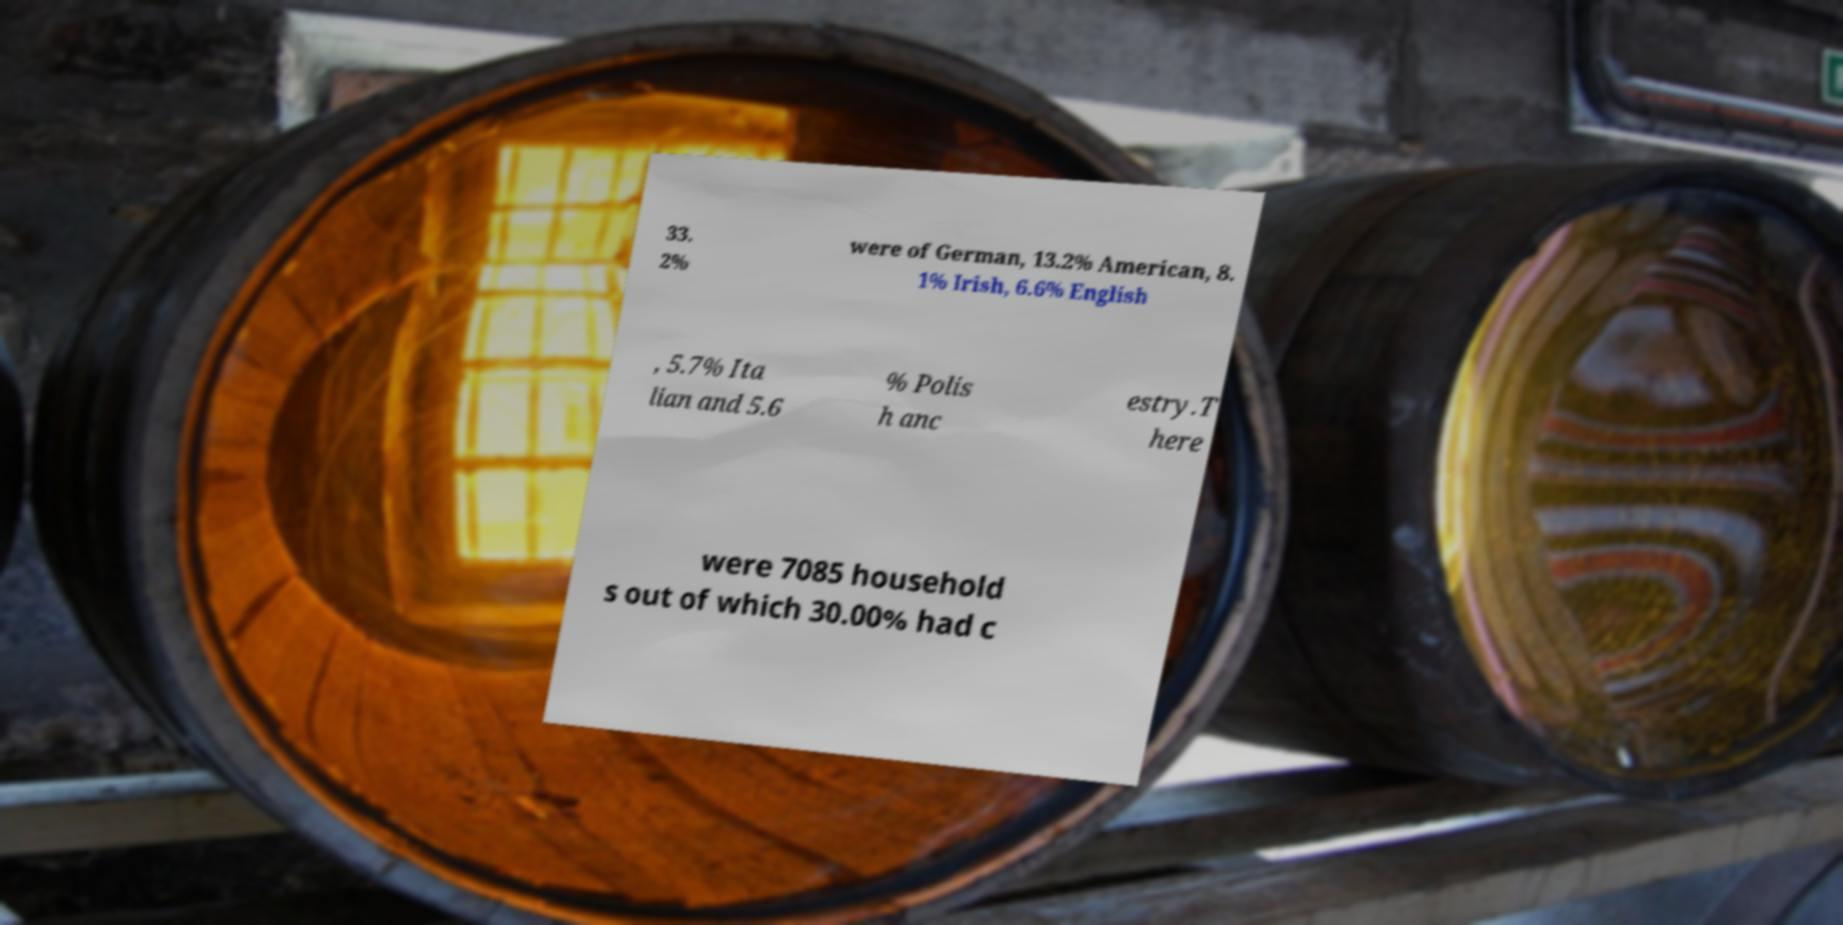Can you read and provide the text displayed in the image?This photo seems to have some interesting text. Can you extract and type it out for me? 33. 2% were of German, 13.2% American, 8. 1% Irish, 6.6% English , 5.7% Ita lian and 5.6 % Polis h anc estry.T here were 7085 household s out of which 30.00% had c 